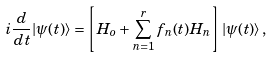<formula> <loc_0><loc_0><loc_500><loc_500>i \frac { d } { d t } | \psi ( t ) \rangle = \left [ H _ { o } + \sum _ { n = 1 } ^ { r } f _ { n } ( t ) H _ { n } \right ] | \psi ( t ) \rangle \, ,</formula> 